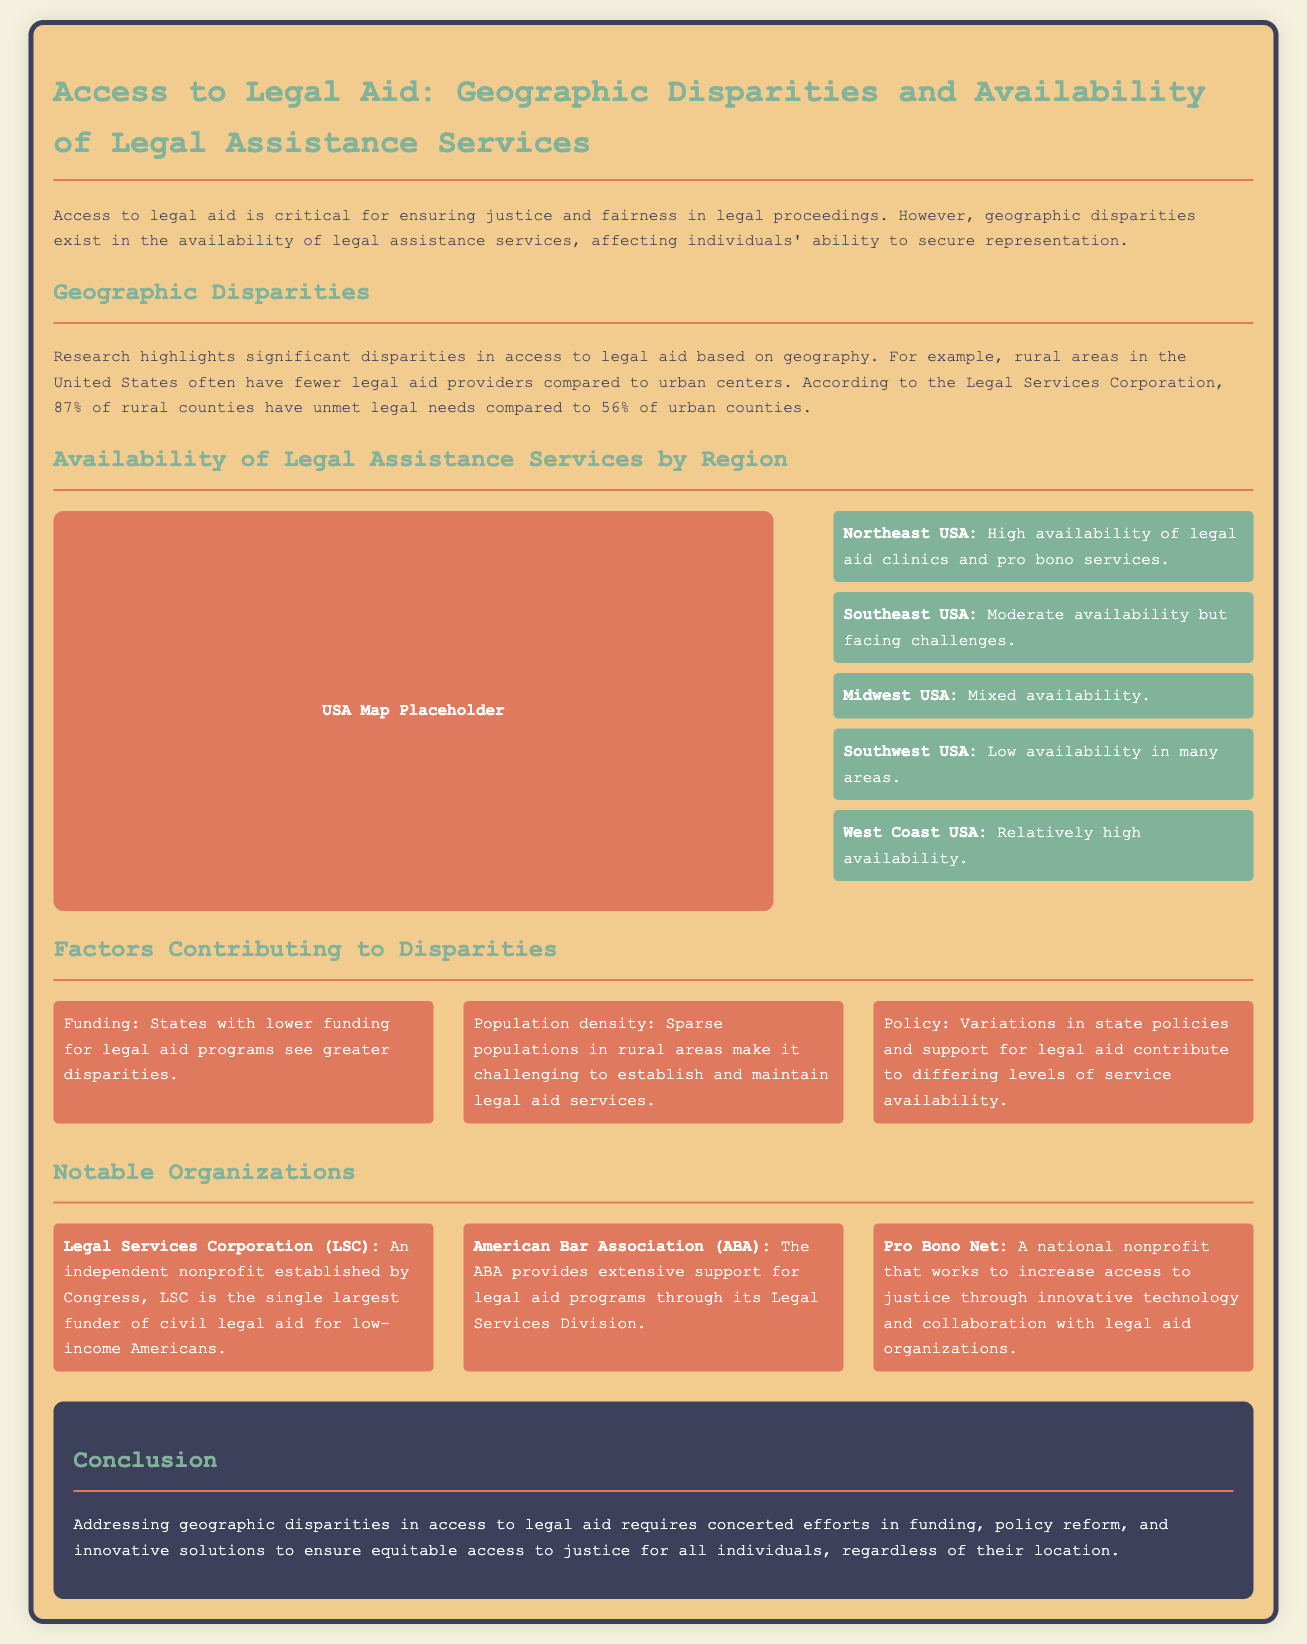What percentage of rural counties have unmet legal needs? The percentage of rural counties with unmet legal needs is stated in the document to be 87%.
Answer: 87% Which organization is the single largest funder of civil legal aid for low-income Americans? The document specifies that the Legal Services Corporation (LSC) is the single largest funder of civil legal aid for low-income Americans.
Answer: Legal Services Corporation (LSC) What is the availability status in the Southeast USA region? The document describes the availability of legal aid in the Southeast USA as moderate but facing challenges.
Answer: Moderate availability but facing challenges What are the three factors contributing to disparities in legal aid access? The document lists funding, population density, and policy as the three factors contributing to disparities in access to legal aid.
Answer: Funding, population density, policy Which region in the USA has the highest availability of legal aid clinics? According to the document, the Northeast USA has high availability of legal aid clinics and pro bono services.
Answer: Northeast USA What is the overall conclusion regarding geographic disparities in access to legal aid? The document concludes that addressing geographic disparities requires concerted efforts in funding, policy reform, and innovative solutions.
Answer: Concerted efforts in funding, policy reform, and innovative solutions What is the primary function of Pro Bono Net as mentioned in the document? The document indicates that Pro Bono Net works to increase access to justice through innovative technology and collaboration with legal aid organizations.
Answer: Increase access to justice through innovative technology In terms of availability, how does the Midwest USA fare? The document characterizes the availability of legal aid in the Midwest USA as mixed.
Answer: Mixed availability 